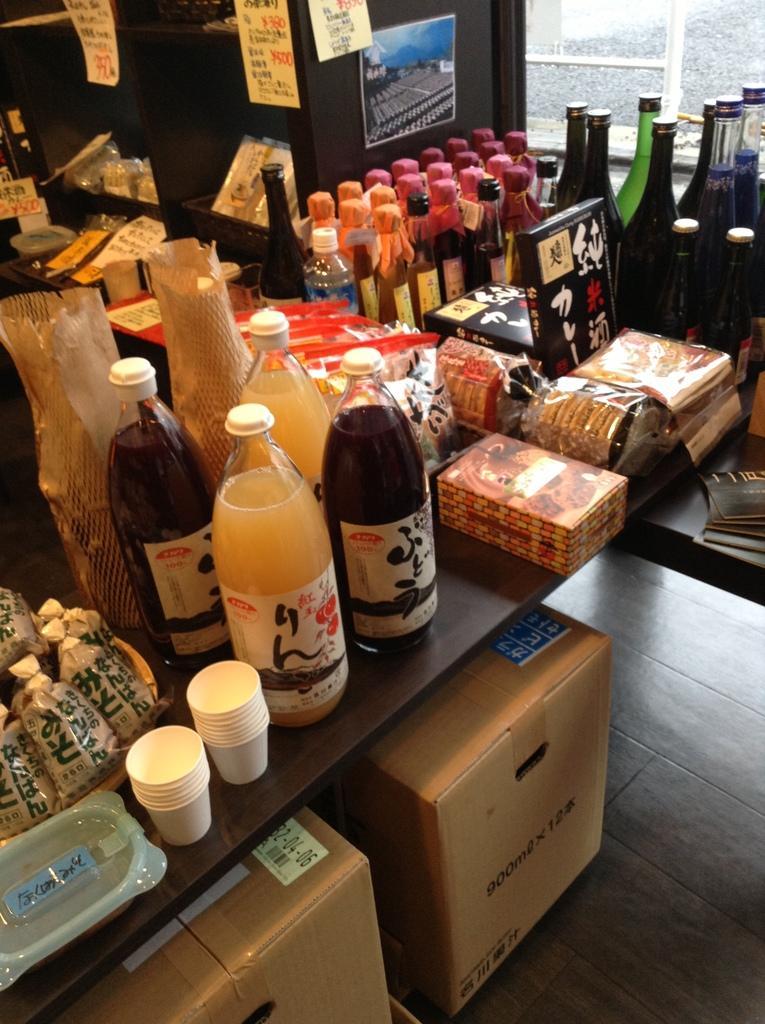How would you summarize this image in a sentence or two? In this image I see a number of bottles, few boxes, cups and covers and I can also see there are 2 boxes over here. 